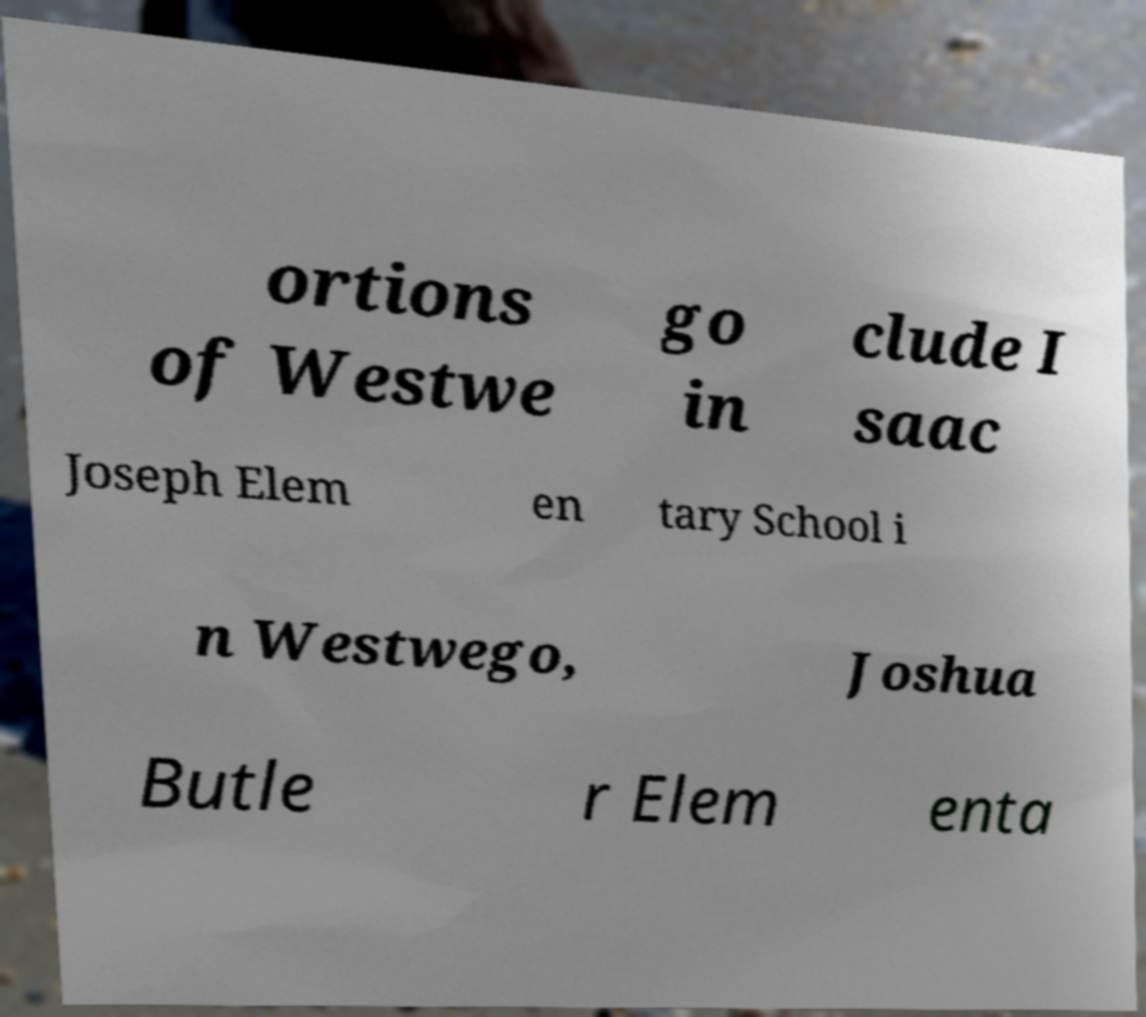Could you assist in decoding the text presented in this image and type it out clearly? ortions of Westwe go in clude I saac Joseph Elem en tary School i n Westwego, Joshua Butle r Elem enta 